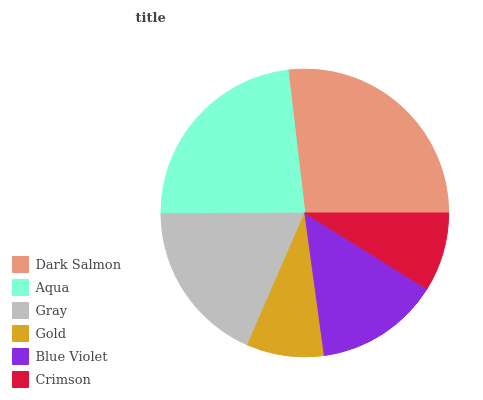Is Gold the minimum?
Answer yes or no. Yes. Is Dark Salmon the maximum?
Answer yes or no. Yes. Is Aqua the minimum?
Answer yes or no. No. Is Aqua the maximum?
Answer yes or no. No. Is Dark Salmon greater than Aqua?
Answer yes or no. Yes. Is Aqua less than Dark Salmon?
Answer yes or no. Yes. Is Aqua greater than Dark Salmon?
Answer yes or no. No. Is Dark Salmon less than Aqua?
Answer yes or no. No. Is Gray the high median?
Answer yes or no. Yes. Is Blue Violet the low median?
Answer yes or no. Yes. Is Crimson the high median?
Answer yes or no. No. Is Aqua the low median?
Answer yes or no. No. 